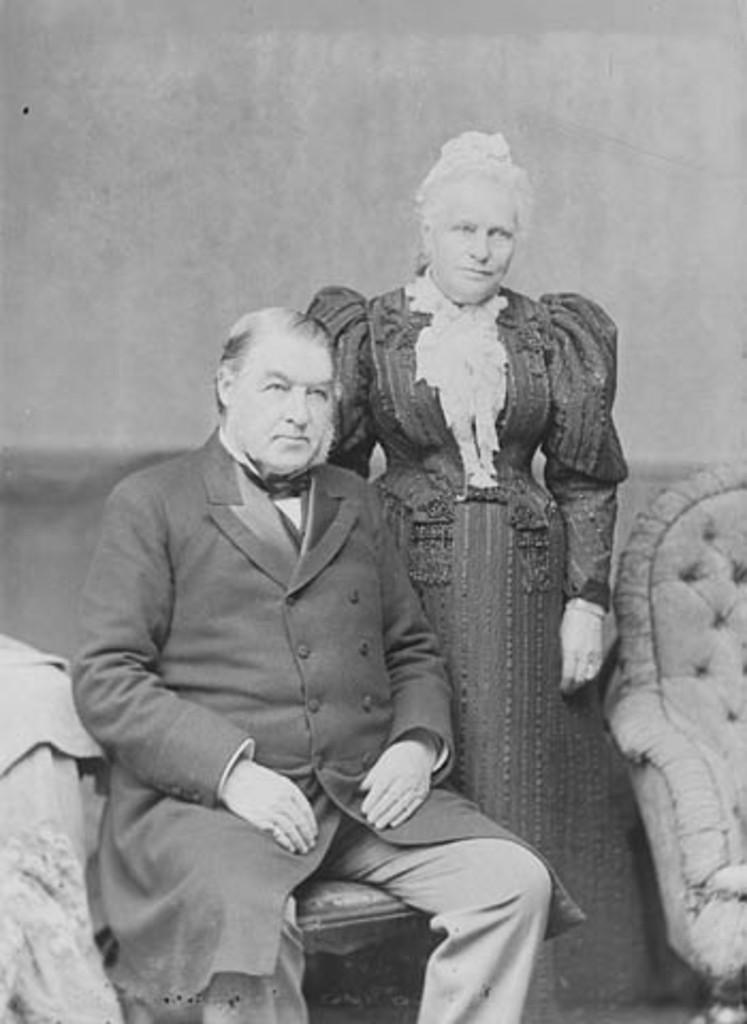What is the color scheme of the image? The image is black and white. What is the man in the image doing? The man is sitting on a chair in the image. Who is with the man in the image? There is a woman standing beside the man in the image. What type of jar is the man holding in the image? There is no jar present in the image; the man is sitting on a chair and the woman is standing beside him. 